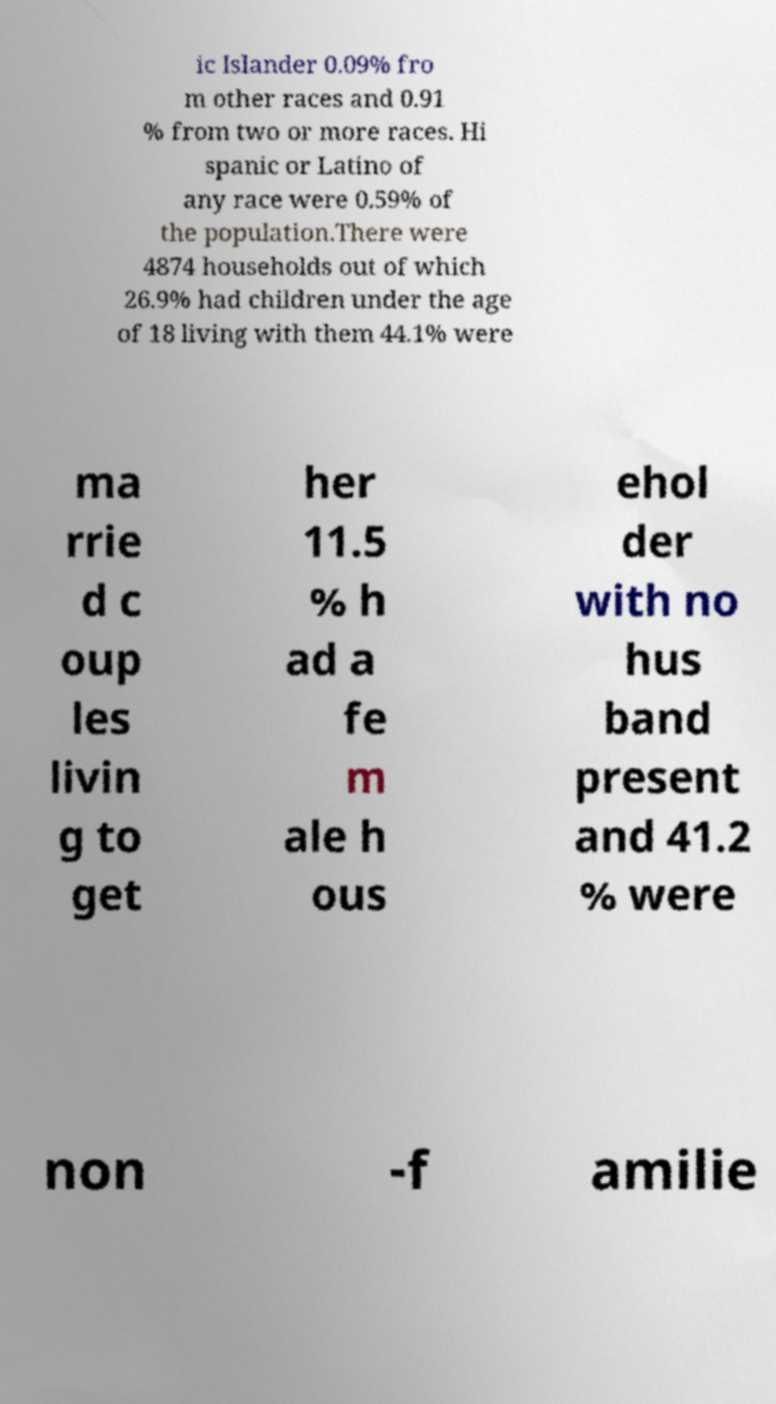Can you accurately transcribe the text from the provided image for me? ic Islander 0.09% fro m other races and 0.91 % from two or more races. Hi spanic or Latino of any race were 0.59% of the population.There were 4874 households out of which 26.9% had children under the age of 18 living with them 44.1% were ma rrie d c oup les livin g to get her 11.5 % h ad a fe m ale h ous ehol der with no hus band present and 41.2 % were non -f amilie 